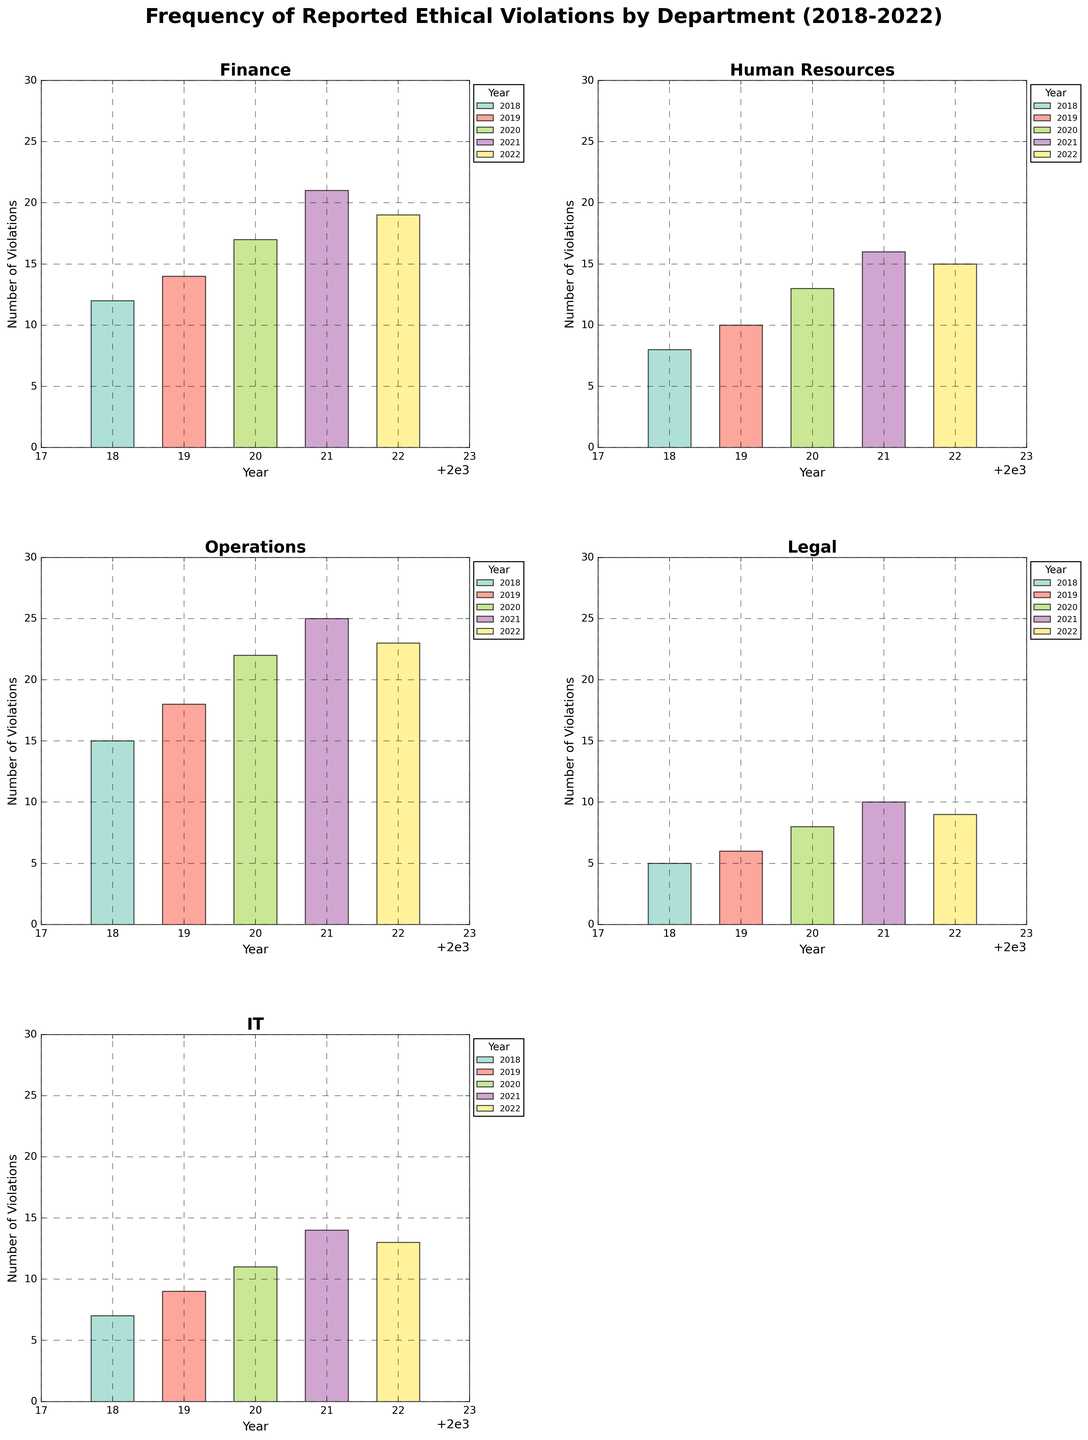What is the title of the figure? The title is generally found at the top center of a plot, providing a summary description of what the graph depicts. Here, it is explicitly mentioned as "Frequency of Reported Ethical Violations by Department (2018-2022)."
Answer: Frequency of Reported Ethical Violations by Department (2018-2022) Which department reported the highest number of violations in 2021? To determine this, we look at the 2021 bar heights in each subplot. The tallest bar corresponds to the Operations department, indicating the highest number of violations.
Answer: Operations How did the number of violations in the Finance department change from 2018 to 2022? By comparing the heights of the bars for Finance in 2018 and 2022, we see they increased from 12 in 2018 to 19 in 2022.
Answer: Increased from 12 to 19 Which year had the highest overall number of violations for the Legal department? Checking the highest bar in the Legal department subplot indicates that 2021 had the highest violations, with 10 reported instances.
Answer: 2021 Compare the number of violations between the IT and Human Resources departments in 2020. Which department had more violations? By examining the bar heights for 2020 in both the IT and Human Resources subplots, we see Human Resources reported 13 violations and IT reported 11.
Answer: Human Resources For the Operations department, how many total violations were reported from 2018 to 2022? Summing the heights of the bars in the Operations subplot across all years: 15 (2018) + 18 (2019) + 22 (2020) + 25 (2021) + 23 (2022) = 103 total violations.
Answer: 103 Did the number of violations in the IT department increase or decrease between 2019 and 2021? Looking at 2019 and 2021 bars for IT: the number rose from 9 in 2019 to 14 in 2021. Thus, there was an increase.
Answer: Increased Which department had the least number of ethical violations in 2018? Comparing the smallest bar in the respective 2018 subplots, the Legal department had the fewest violations with 5.
Answer: Legal Was the number of violations reported in 2020 higher or lower than in 2019 for the Human Resources department? Observing the heights of the Human Resources bars for 2019 and 2020, violations increased from 10 in 2019 to 13 in 2020.
Answer: Higher 